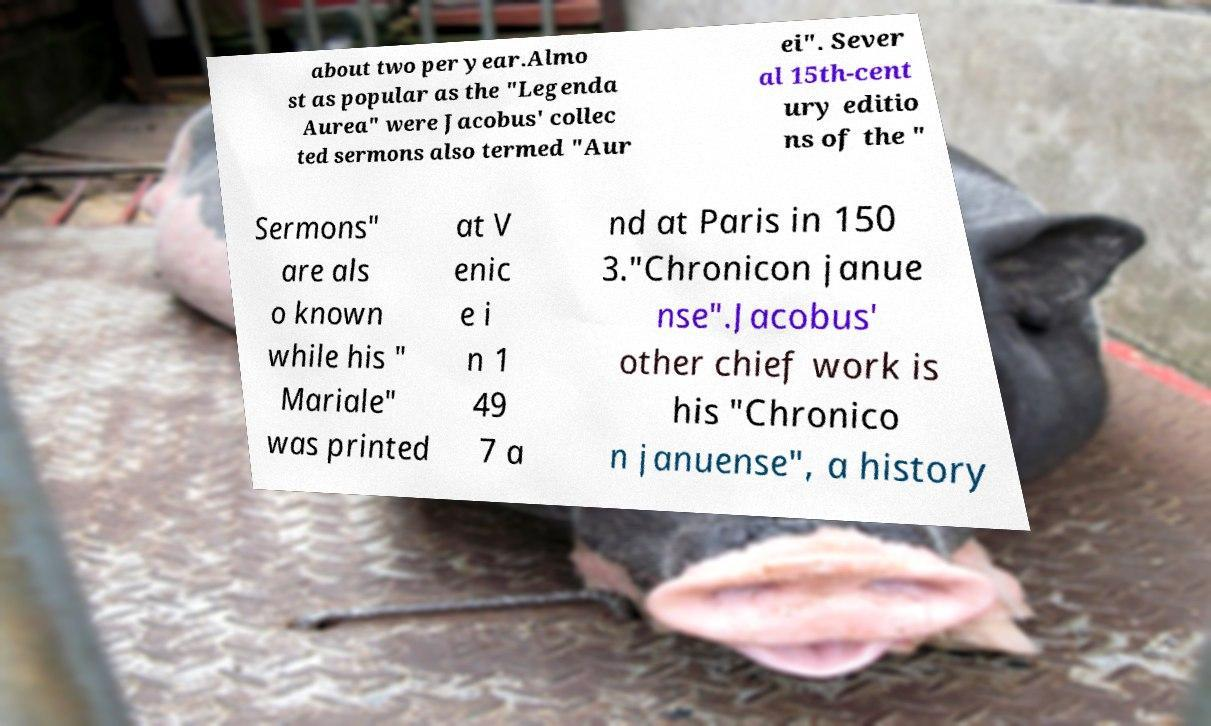Could you assist in decoding the text presented in this image and type it out clearly? about two per year.Almo st as popular as the "Legenda Aurea" were Jacobus' collec ted sermons also termed "Aur ei". Sever al 15th-cent ury editio ns of the " Sermons" are als o known while his " Mariale" was printed at V enic e i n 1 49 7 a nd at Paris in 150 3."Chronicon janue nse".Jacobus' other chief work is his "Chronico n januense", a history 